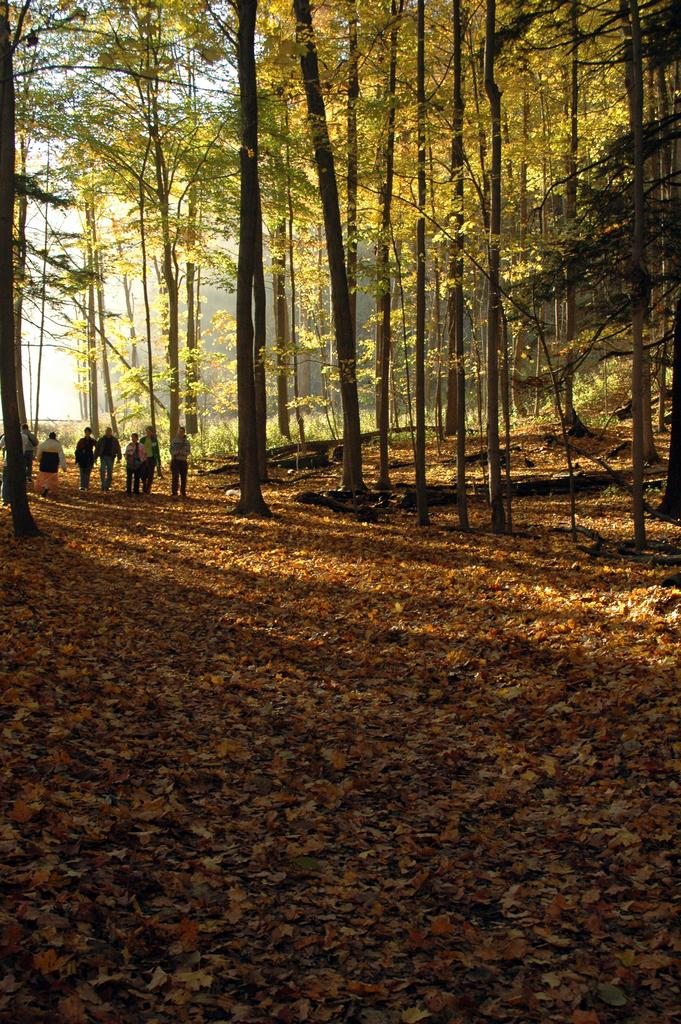What is present on the ground in the foreground of the image? There are leaves on the ground in the foreground. What can be seen in the background of the image? There are persons visible in the background, along with trees. What type of ice can be seen melting in the hands of the persons in the background? There is no ice present in the image, and the persons in the background do not have their hands visible. 